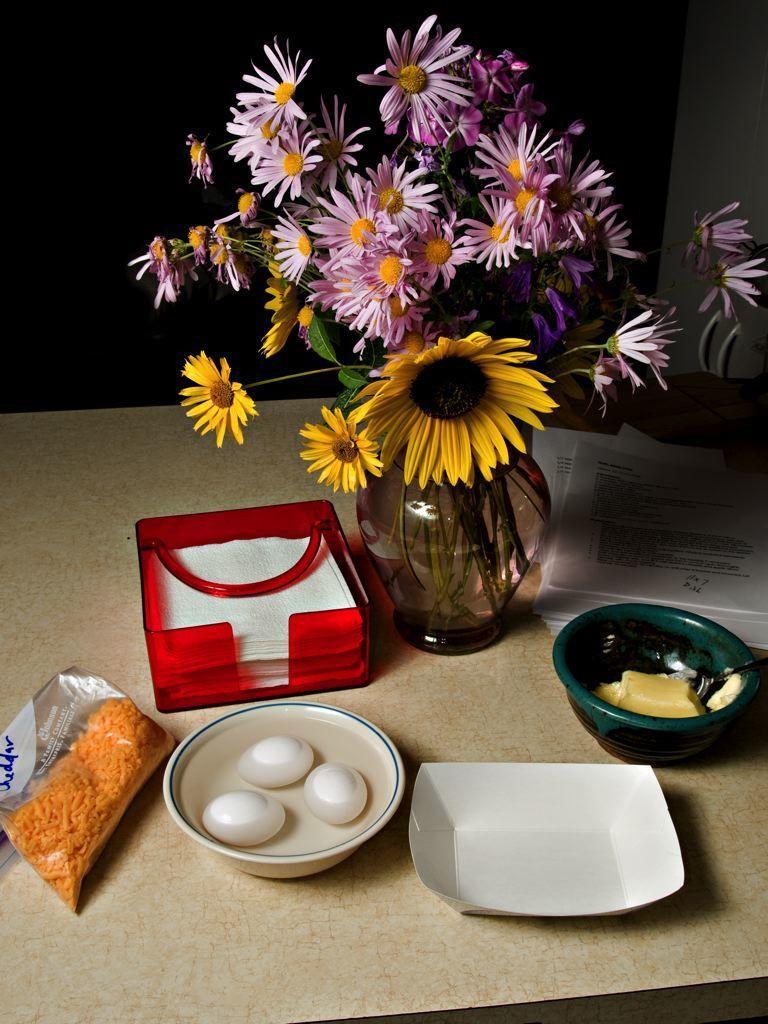In one or two sentences, can you explain what this image depicts? This image consists of a flower pot and bowls in which there are eggs kept on a table. And there is a tissue box in red color. 